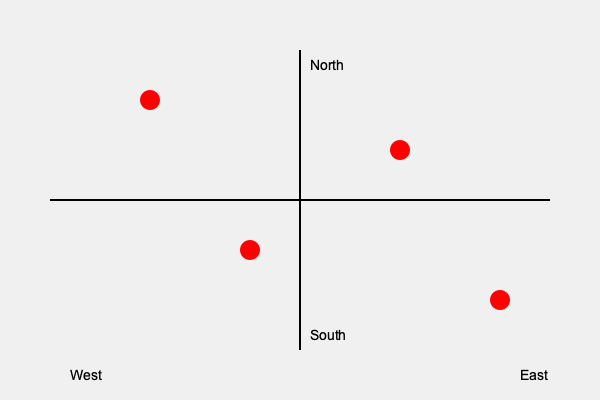Given the spatial distribution of military attaché offices represented by red dots on the world map, which quadrant contains the highest concentration of offices, and what might this suggest about diplomatic priorities? To analyze the spatial distribution of military attaché offices:

1. Divide the map into quadrants:
   - Northwest (NW): Upper-left
   - Northeast (NE): Upper-right
   - Southwest (SW): Lower-left
   - Southeast (SE): Lower-right

2. Count the number of offices in each quadrant:
   - NW: 1 office
   - NE: 1 office
   - SW: 1 office
   - SE: 1 office

3. Determine the quadrant with the highest concentration:
   - All quadrants have an equal number of offices (1 each)

4. Interpret the distribution:
   - The even distribution suggests a balanced approach to diplomatic priorities
   - No single region is given significantly more attention than others

5. Consider implications for international relations:
   - Equal representation may indicate a global diplomatic strategy
   - The country maintains a consistent presence across different world regions
   - This approach could facilitate balanced information gathering and relationship building

6. Reflect on the role of military attachés:
   - Their presence in all quadrants suggests a comprehensive security strategy
   - The country aims to maintain military diplomatic ties globally

The even distribution across all quadrants suggests a balanced global approach to military diplomacy, with no clear regional prioritization.
Answer: Even distribution; balanced global approach 